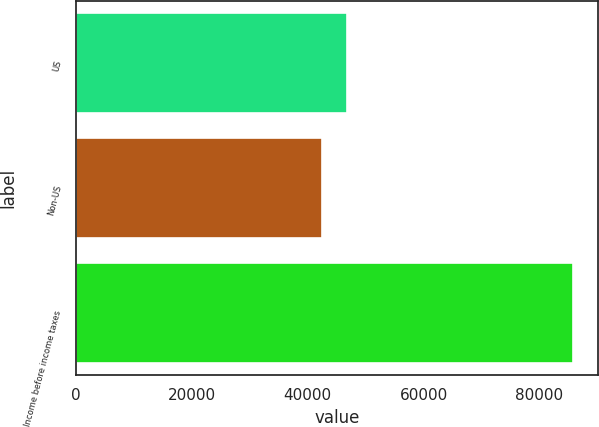Convert chart to OTSL. <chart><loc_0><loc_0><loc_500><loc_500><bar_chart><fcel>US<fcel>Non-US<fcel>Income before income taxes<nl><fcel>46796.7<fcel>42455<fcel>85872<nl></chart> 